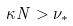<formula> <loc_0><loc_0><loc_500><loc_500>\kappa N > \nu _ { * }</formula> 